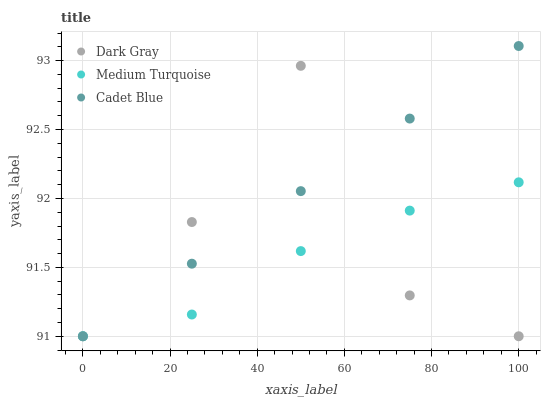Does Medium Turquoise have the minimum area under the curve?
Answer yes or no. Yes. Does Cadet Blue have the maximum area under the curve?
Answer yes or no. Yes. Does Cadet Blue have the minimum area under the curve?
Answer yes or no. No. Does Medium Turquoise have the maximum area under the curve?
Answer yes or no. No. Is Cadet Blue the smoothest?
Answer yes or no. Yes. Is Dark Gray the roughest?
Answer yes or no. Yes. Is Medium Turquoise the smoothest?
Answer yes or no. No. Is Medium Turquoise the roughest?
Answer yes or no. No. Does Dark Gray have the lowest value?
Answer yes or no. Yes. Does Cadet Blue have the highest value?
Answer yes or no. Yes. Does Medium Turquoise have the highest value?
Answer yes or no. No. Does Cadet Blue intersect Dark Gray?
Answer yes or no. Yes. Is Cadet Blue less than Dark Gray?
Answer yes or no. No. Is Cadet Blue greater than Dark Gray?
Answer yes or no. No. 